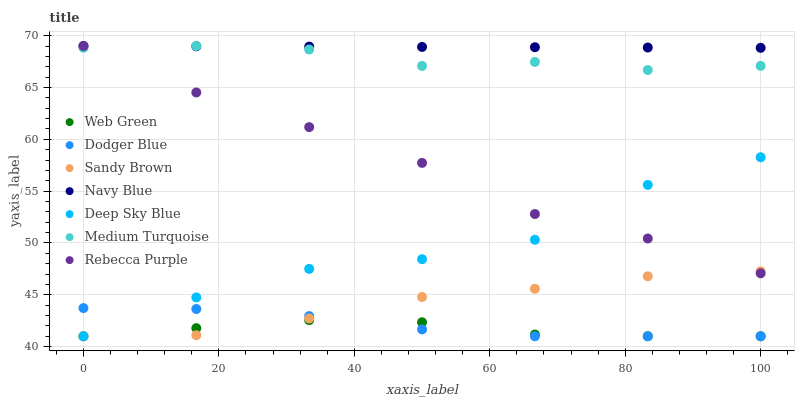Does Web Green have the minimum area under the curve?
Answer yes or no. Yes. Does Navy Blue have the maximum area under the curve?
Answer yes or no. Yes. Does Navy Blue have the minimum area under the curve?
Answer yes or no. No. Does Web Green have the maximum area under the curve?
Answer yes or no. No. Is Navy Blue the smoothest?
Answer yes or no. Yes. Is Deep Sky Blue the roughest?
Answer yes or no. Yes. Is Web Green the smoothest?
Answer yes or no. No. Is Web Green the roughest?
Answer yes or no. No. Does Deep Sky Blue have the lowest value?
Answer yes or no. Yes. Does Navy Blue have the lowest value?
Answer yes or no. No. Does Medium Turquoise have the highest value?
Answer yes or no. Yes. Does Web Green have the highest value?
Answer yes or no. No. Is Web Green less than Rebecca Purple?
Answer yes or no. Yes. Is Navy Blue greater than Deep Sky Blue?
Answer yes or no. Yes. Does Web Green intersect Dodger Blue?
Answer yes or no. Yes. Is Web Green less than Dodger Blue?
Answer yes or no. No. Is Web Green greater than Dodger Blue?
Answer yes or no. No. Does Web Green intersect Rebecca Purple?
Answer yes or no. No. 